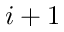<formula> <loc_0><loc_0><loc_500><loc_500>i + 1</formula> 